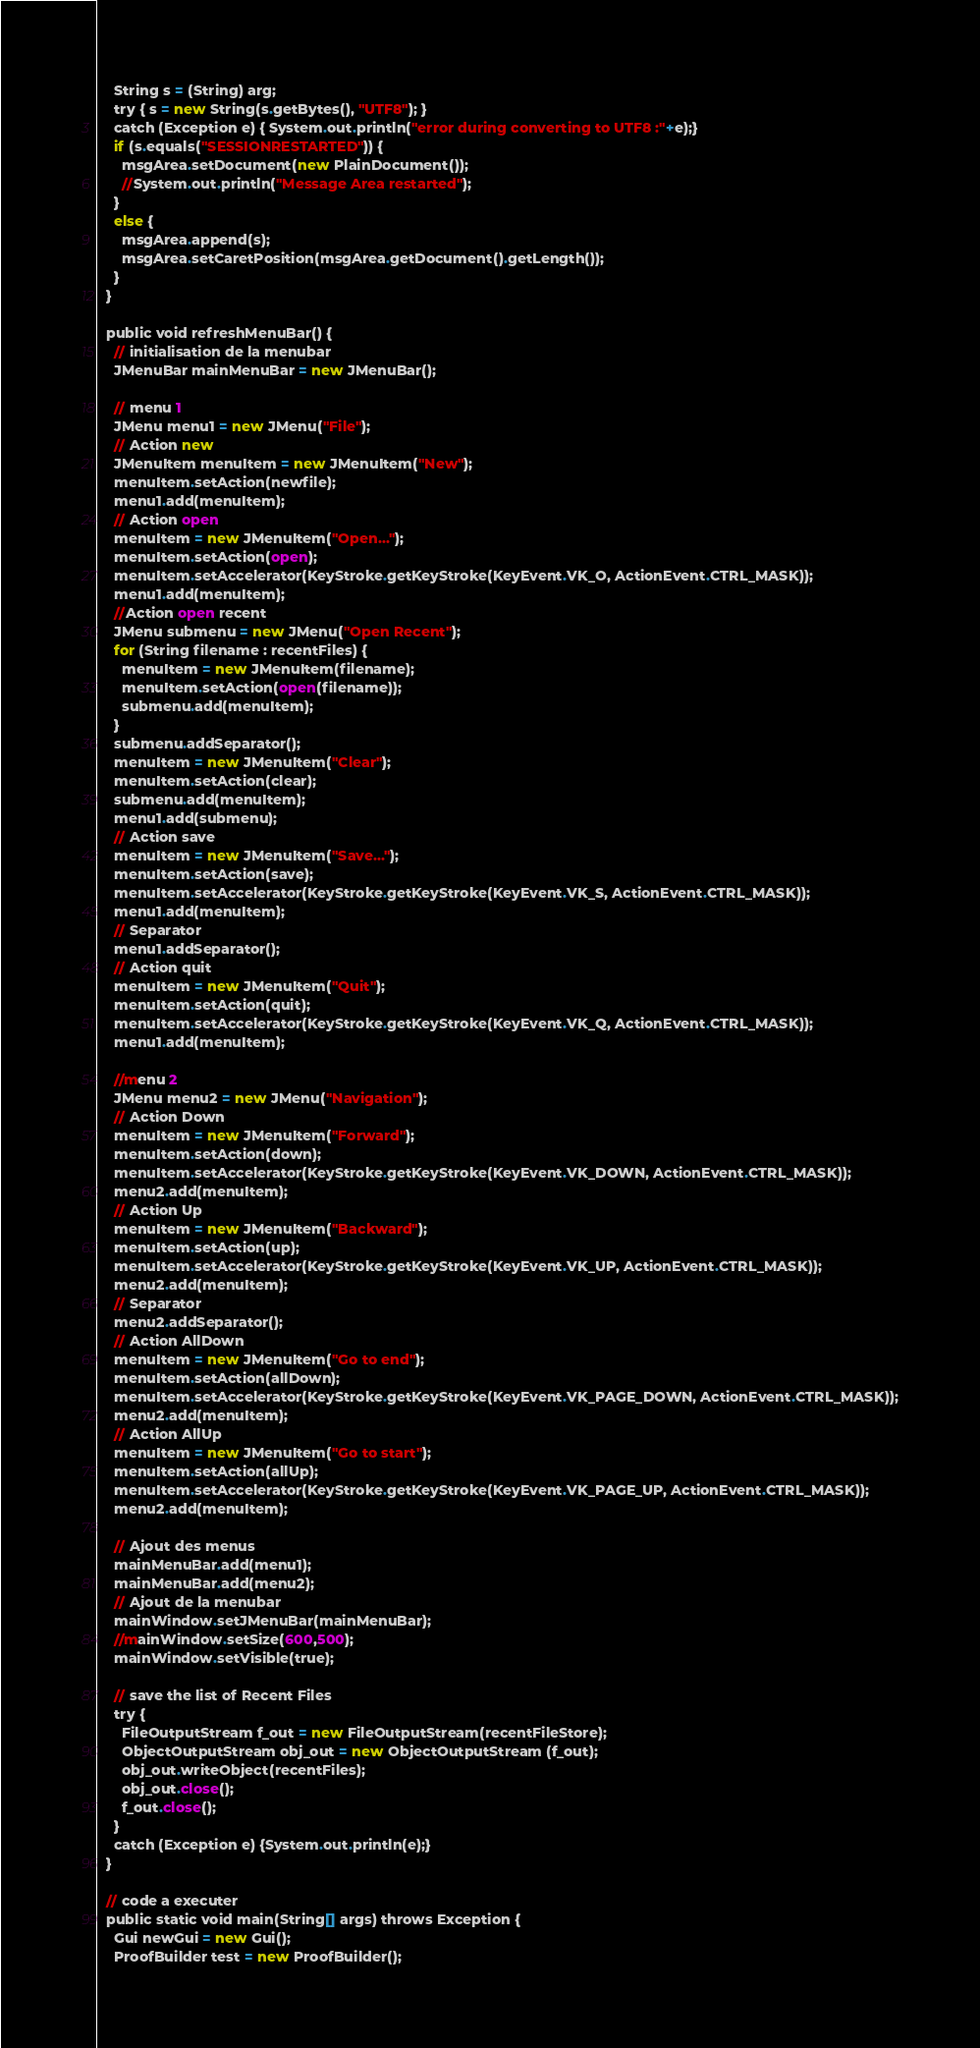<code> <loc_0><loc_0><loc_500><loc_500><_Perl_>    String s = (String) arg;
    try { s = new String(s.getBytes(), "UTF8"); }
    catch (Exception e) { System.out.println("error during converting to UTF8 :"+e);}
    if (s.equals("SESSIONRESTARTED")) {
      msgArea.setDocument(new PlainDocument());
      //System.out.println("Message Area restarted");
    }
    else {
      msgArea.append(s);
      msgArea.setCaretPosition(msgArea.getDocument().getLength());
    }
  }

  public void refreshMenuBar() {
    // initialisation de la menubar
    JMenuBar mainMenuBar = new JMenuBar();
    
    // menu 1
    JMenu menu1 = new JMenu("File");
    // Action new
    JMenuItem menuItem = new JMenuItem("New");
    menuItem.setAction(newfile);
    menu1.add(menuItem);
    // Action open
    menuItem = new JMenuItem("Open...");
    menuItem.setAction(open);
    menuItem.setAccelerator(KeyStroke.getKeyStroke(KeyEvent.VK_O, ActionEvent.CTRL_MASK));
    menu1.add(menuItem);
    //Action open recent
    JMenu submenu = new JMenu("Open Recent");
    for (String filename : recentFiles) {
      menuItem = new JMenuItem(filename);
      menuItem.setAction(open(filename));
      submenu.add(menuItem);
    }
    submenu.addSeparator();
    menuItem = new JMenuItem("Clear");
    menuItem.setAction(clear);
    submenu.add(menuItem);
    menu1.add(submenu);
    // Action save
    menuItem = new JMenuItem("Save...");
    menuItem.setAction(save);
    menuItem.setAccelerator(KeyStroke.getKeyStroke(KeyEvent.VK_S, ActionEvent.CTRL_MASK));
    menu1.add(menuItem);
    // Separator
    menu1.addSeparator();
    // Action quit
    menuItem = new JMenuItem("Quit");
    menuItem.setAction(quit);
    menuItem.setAccelerator(KeyStroke.getKeyStroke(KeyEvent.VK_Q, ActionEvent.CTRL_MASK));
    menu1.add(menuItem);

    //menu 2
    JMenu menu2 = new JMenu("Navigation");
    // Action Down
    menuItem = new JMenuItem("Forward");
    menuItem.setAction(down);
    menuItem.setAccelerator(KeyStroke.getKeyStroke(KeyEvent.VK_DOWN, ActionEvent.CTRL_MASK));
    menu2.add(menuItem);
    // Action Up
    menuItem = new JMenuItem("Backward");
    menuItem.setAction(up);
    menuItem.setAccelerator(KeyStroke.getKeyStroke(KeyEvent.VK_UP, ActionEvent.CTRL_MASK));
    menu2.add(menuItem);
    // Separator
    menu2.addSeparator();
    // Action AllDown
    menuItem = new JMenuItem("Go to end");
    menuItem.setAction(allDown);
    menuItem.setAccelerator(KeyStroke.getKeyStroke(KeyEvent.VK_PAGE_DOWN, ActionEvent.CTRL_MASK));
    menu2.add(menuItem);
    // Action AllUp
    menuItem = new JMenuItem("Go to start");
    menuItem.setAction(allUp);
    menuItem.setAccelerator(KeyStroke.getKeyStroke(KeyEvent.VK_PAGE_UP, ActionEvent.CTRL_MASK));
    menu2.add(menuItem);
    
    // Ajout des menus
    mainMenuBar.add(menu1);
    mainMenuBar.add(menu2);
    // Ajout de la menubar
    mainWindow.setJMenuBar(mainMenuBar);
    //mainWindow.setSize(600,500);
    mainWindow.setVisible(true);
    
    // save the list of Recent Files
    try {
      FileOutputStream f_out = new FileOutputStream(recentFileStore);
      ObjectOutputStream obj_out = new ObjectOutputStream (f_out);
      obj_out.writeObject(recentFiles);
      obj_out.close();
      f_out.close();
    }
    catch (Exception e) {System.out.println(e);}
  }

  // code a executer
  public static void main(String[] args) throws Exception {
    Gui newGui = new Gui();
    ProofBuilder test = new ProofBuilder();</code> 